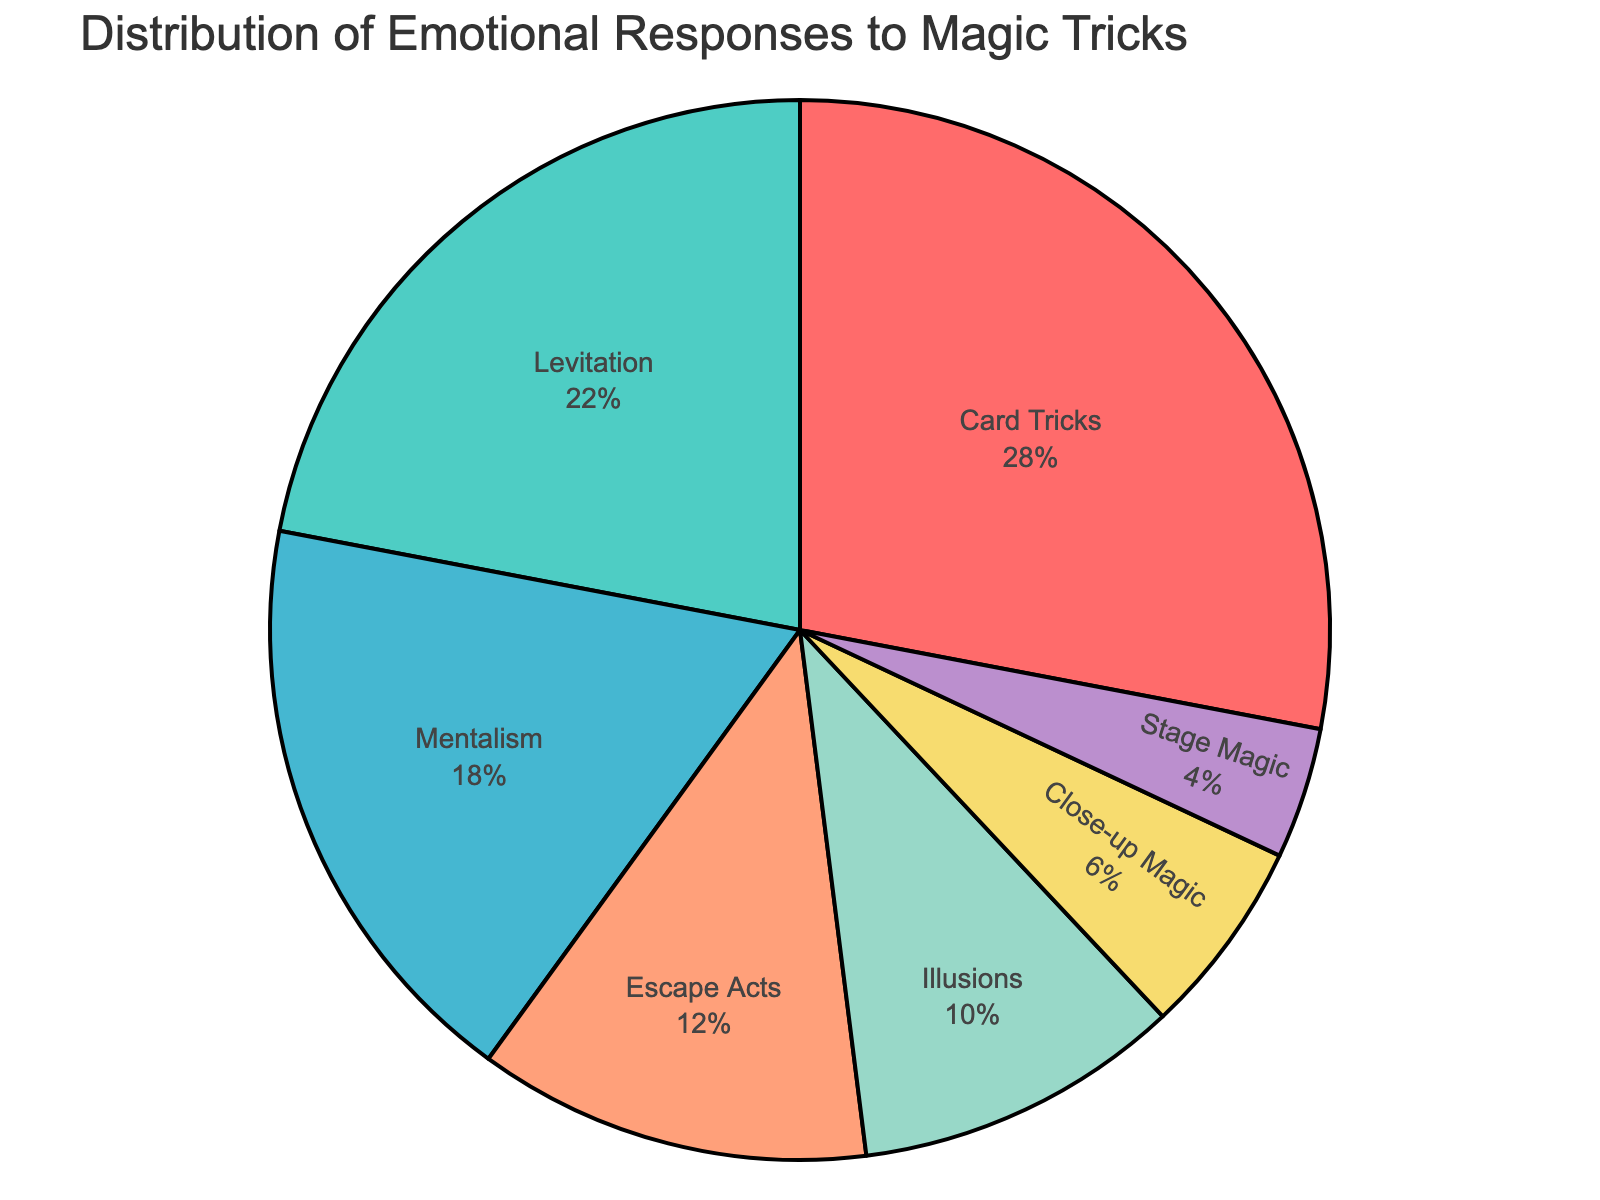Which trick type has the highest percentage of emotional responses? The segment with the largest visual area and label is “Card Tricks” with 28%.
Answer: Card Tricks What is the total percentage of emotional responses for Escape Acts and Close-up Magic? Add the percentage values for Escape Acts (12%) and Close-up Magic (6%) together, which gives 12 + 6 = 18%.
Answer: 18% Is the percentage of emotional responses for Levitation greater than that for Illusions? Compare the percentage values: Levitation has 22%, and Illusions have 10%. Since 22% is greater than 10%, the answer is yes.
Answer: Yes Which trick type has the smallest percentage of emotional responses? The segment with the smallest visual area and label shows “Stage Magic” with 4%.
Answer: Stage Magic What is the combined percentage of emotional responses for the three types with the lowest percentages? Add the percentages for Escape Acts (12%), Close-up Magic (6%), and Stage Magic (4%). This gives 12 + 6 + 4 = 22%.
Answer: 22% What is the difference in emotional responses between the trick type with the highest percentage and the trick type with the lowest percentage? Subtract the lowest percentage (Stage Magic, 4%) from the highest percentage (Card Tricks, 28%), which gives 28 - 4 = 24%.
Answer: 24% Are the combined emotional responses for Illusions and Close-up Magic less than or equal to those for Mentalism? Add the percentages for Illusions (10%) and Close-up Magic (6%), which gives 10 + 6 = 16%. Compare this sum to Mentalism, which has 18%. Since 16% is less than 18%, the answer is yes.
Answer: Yes What is the average percentage of emotional responses for Mentalism and Levitation? Add the percentages for Mentalism (18%) and Levitation (22%) to get 40. Then divide by 2 to get the average, which is 40 / 2 = 20%.
Answer: 20% What is the ratio of emotional responses for Card Tricks to those for Levitation? Divide the percentage for Card Tricks (28%) by that for Levitation (22%), which gives a ratio of 28 / 22 = 1.27.
Answer: 1.27 Which has a higher percentage: the combined emotional responses for Illusions and Stage Magic, or those for Levitation alone? Add the percentages for Illusions (10%) and Stage Magic (4%) to get 14%. Compare this to Levitation (22%). Since 14% is less than 22%, Levitation has the higher percentage.
Answer: Levitation 